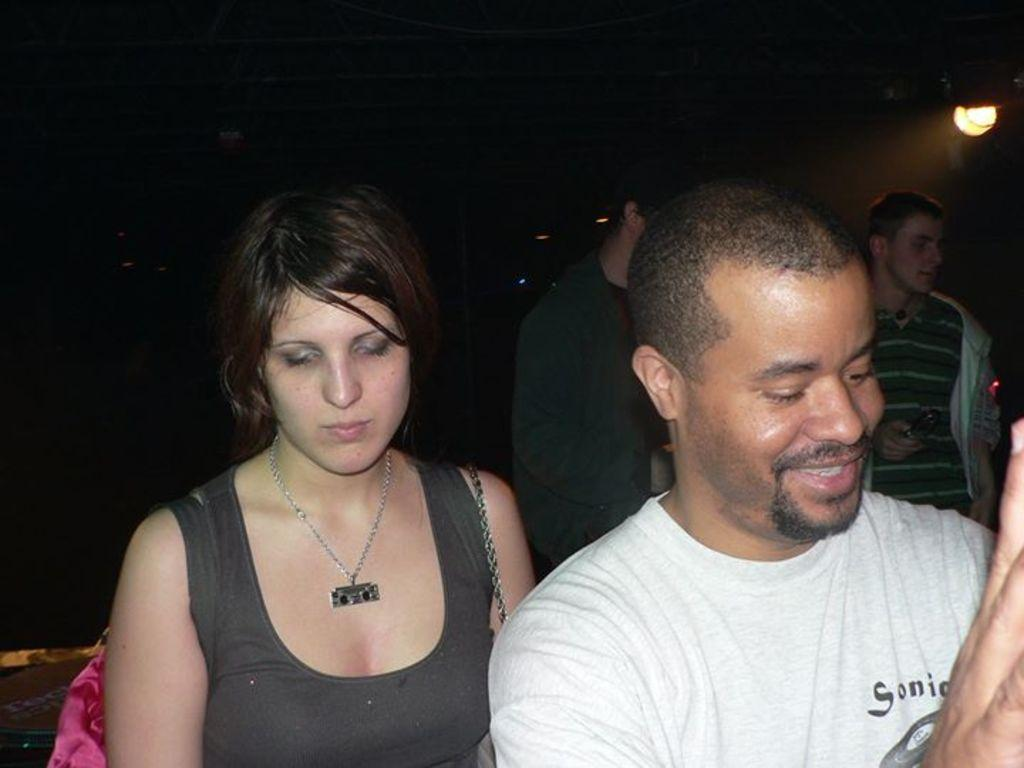What is the main subject of the image? The main subject of the image is a group of people. Can you describe the man on the right side of the image? The man on the right side of the image is smiling. What can be seen in the background of the image? There is a light in the background of the image. What type of popcorn are the girls eating in the image? There are no girls or popcorn present in the image. How can someone join the group in the image? The image does not show a way to join the group, as it is a static image and not an interactive scene. 